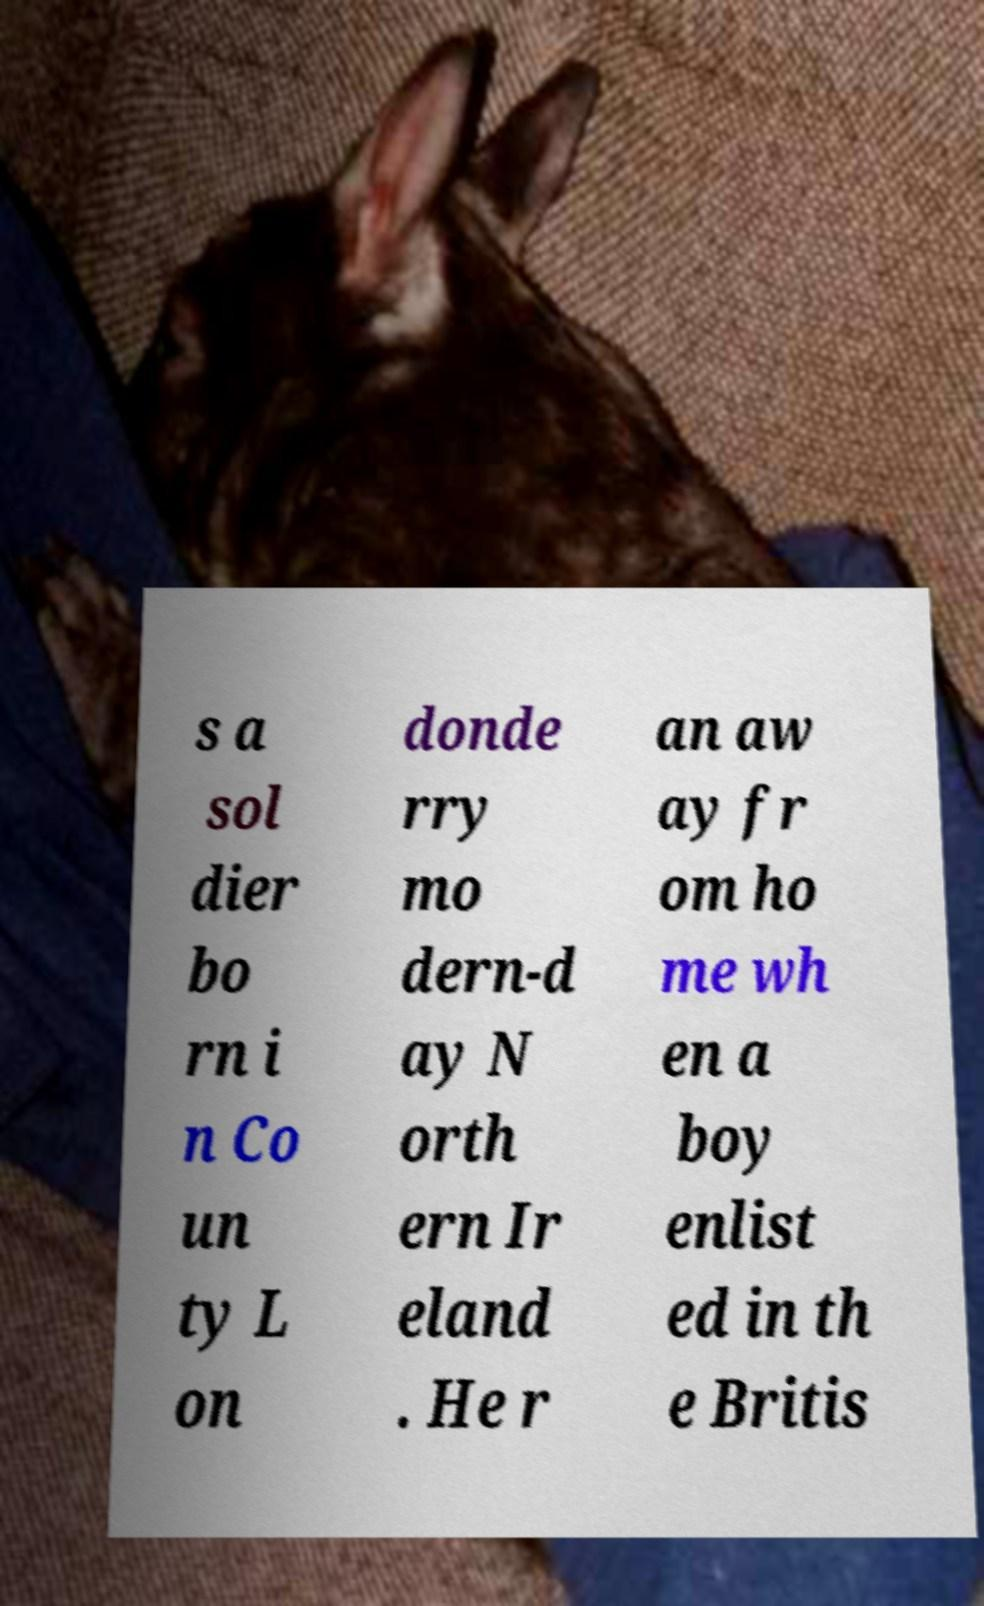What messages or text are displayed in this image? I need them in a readable, typed format. s a sol dier bo rn i n Co un ty L on donde rry mo dern-d ay N orth ern Ir eland . He r an aw ay fr om ho me wh en a boy enlist ed in th e Britis 